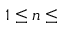<formula> <loc_0><loc_0><loc_500><loc_500>1 \leq n \leq</formula> 